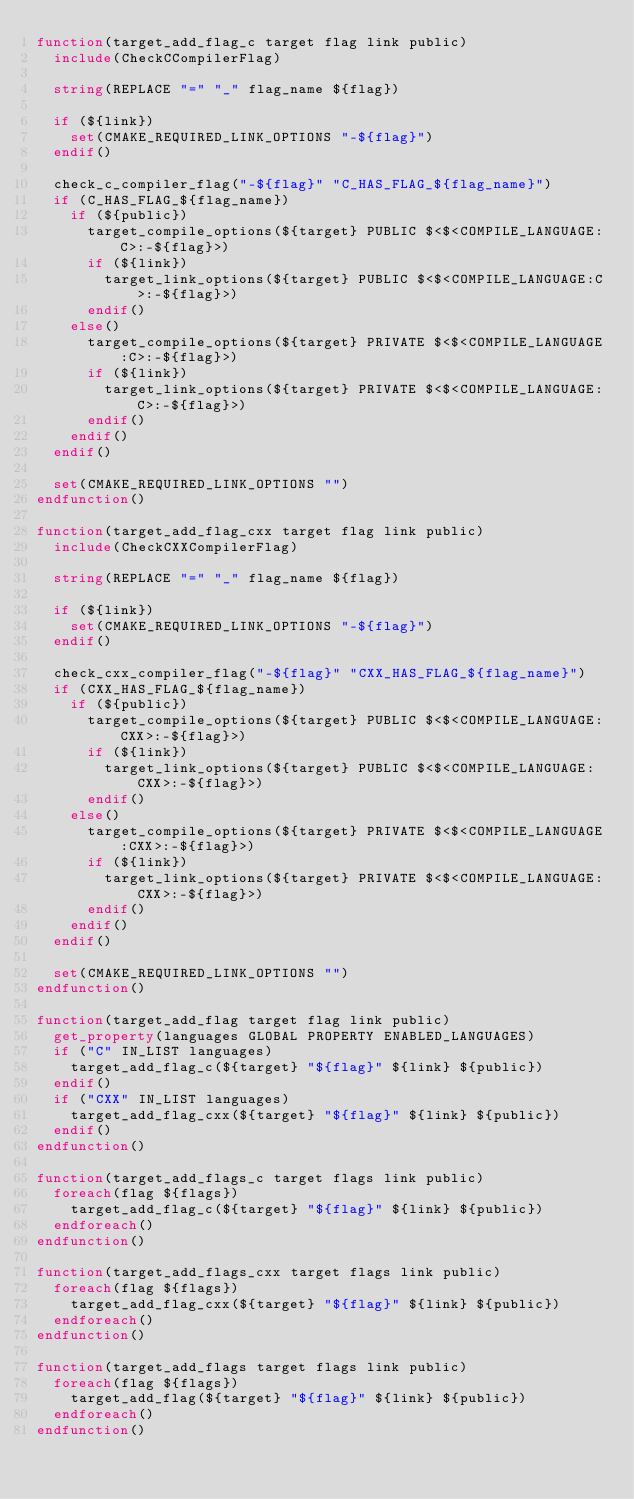Convert code to text. <code><loc_0><loc_0><loc_500><loc_500><_CMake_>function(target_add_flag_c target flag link public)
  include(CheckCCompilerFlag)

  string(REPLACE "=" "_" flag_name ${flag})

  if (${link})
    set(CMAKE_REQUIRED_LINK_OPTIONS "-${flag}")
  endif()

  check_c_compiler_flag("-${flag}" "C_HAS_FLAG_${flag_name}")
  if (C_HAS_FLAG_${flag_name})
    if (${public})
      target_compile_options(${target} PUBLIC $<$<COMPILE_LANGUAGE:C>:-${flag}>)
      if (${link})
        target_link_options(${target} PUBLIC $<$<COMPILE_LANGUAGE:C>:-${flag}>)
      endif()
    else()
      target_compile_options(${target} PRIVATE $<$<COMPILE_LANGUAGE:C>:-${flag}>)
      if (${link})
        target_link_options(${target} PRIVATE $<$<COMPILE_LANGUAGE:C>:-${flag}>)
      endif()
    endif()
  endif()

  set(CMAKE_REQUIRED_LINK_OPTIONS "")
endfunction()

function(target_add_flag_cxx target flag link public)
  include(CheckCXXCompilerFlag)

  string(REPLACE "=" "_" flag_name ${flag})

  if (${link})
    set(CMAKE_REQUIRED_LINK_OPTIONS "-${flag}")
  endif()

  check_cxx_compiler_flag("-${flag}" "CXX_HAS_FLAG_${flag_name}")
  if (CXX_HAS_FLAG_${flag_name})
    if (${public})
      target_compile_options(${target} PUBLIC $<$<COMPILE_LANGUAGE:CXX>:-${flag}>)
      if (${link})
        target_link_options(${target} PUBLIC $<$<COMPILE_LANGUAGE:CXX>:-${flag}>)
      endif()
    else()
      target_compile_options(${target} PRIVATE $<$<COMPILE_LANGUAGE:CXX>:-${flag}>)
      if (${link})
        target_link_options(${target} PRIVATE $<$<COMPILE_LANGUAGE:CXX>:-${flag}>)
      endif()
    endif()
  endif()

  set(CMAKE_REQUIRED_LINK_OPTIONS "")
endfunction()

function(target_add_flag target flag link public)
  get_property(languages GLOBAL PROPERTY ENABLED_LANGUAGES)
  if ("C" IN_LIST languages)
    target_add_flag_c(${target} "${flag}" ${link} ${public})
  endif()
  if ("CXX" IN_LIST languages)
    target_add_flag_cxx(${target} "${flag}" ${link} ${public})
  endif()
endfunction()

function(target_add_flags_c target flags link public)
  foreach(flag ${flags})
    target_add_flag_c(${target} "${flag}" ${link} ${public})
  endforeach()
endfunction()

function(target_add_flags_cxx target flags link public)
  foreach(flag ${flags})
    target_add_flag_cxx(${target} "${flag}" ${link} ${public})
  endforeach()
endfunction()

function(target_add_flags target flags link public)
  foreach(flag ${flags})
    target_add_flag(${target} "${flag}" ${link} ${public})
  endforeach()
endfunction()
</code> 